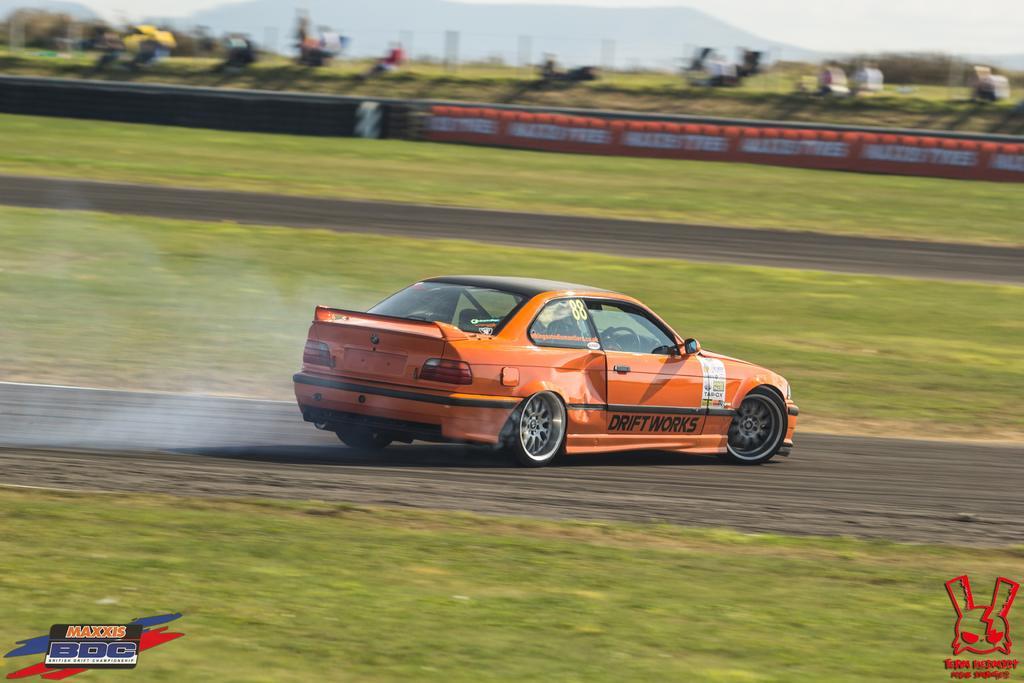In one or two sentences, can you explain what this image depicts? In this picture we can see the orange color car on the racing track. Behind there is a blur background. On the bottom side of the image there are two watermarks. 